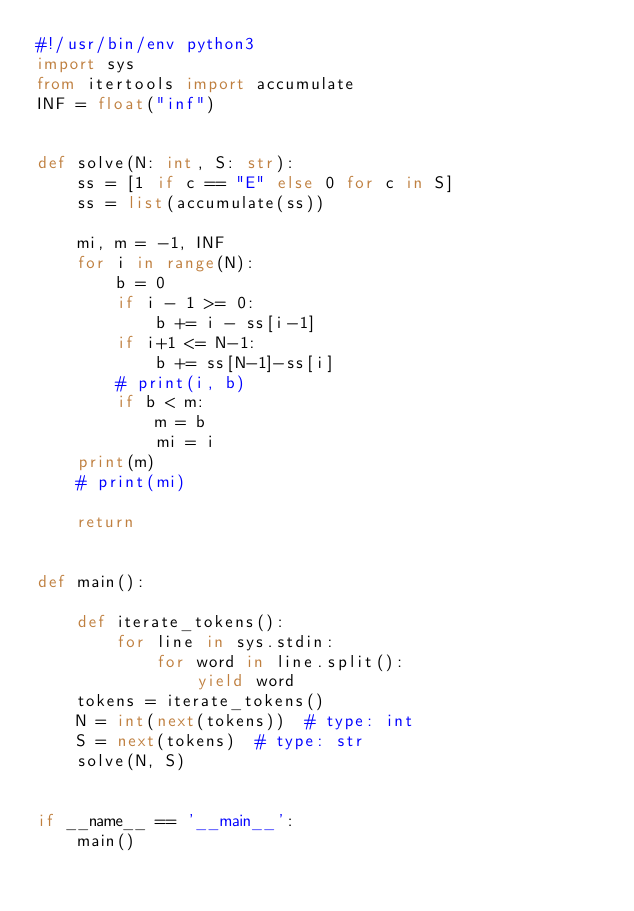<code> <loc_0><loc_0><loc_500><loc_500><_Python_>#!/usr/bin/env python3
import sys
from itertools import accumulate
INF = float("inf")


def solve(N: int, S: str):
    ss = [1 if c == "E" else 0 for c in S]
    ss = list(accumulate(ss))

    mi, m = -1, INF
    for i in range(N):
        b = 0
        if i - 1 >= 0:
            b += i - ss[i-1]
        if i+1 <= N-1:
            b += ss[N-1]-ss[i]
        # print(i, b)
        if b < m:
            m = b
            mi = i
    print(m)
    # print(mi)

    return


def main():

    def iterate_tokens():
        for line in sys.stdin:
            for word in line.split():
                yield word
    tokens = iterate_tokens()
    N = int(next(tokens))  # type: int
    S = next(tokens)  # type: str
    solve(N, S)


if __name__ == '__main__':
    main()
</code> 